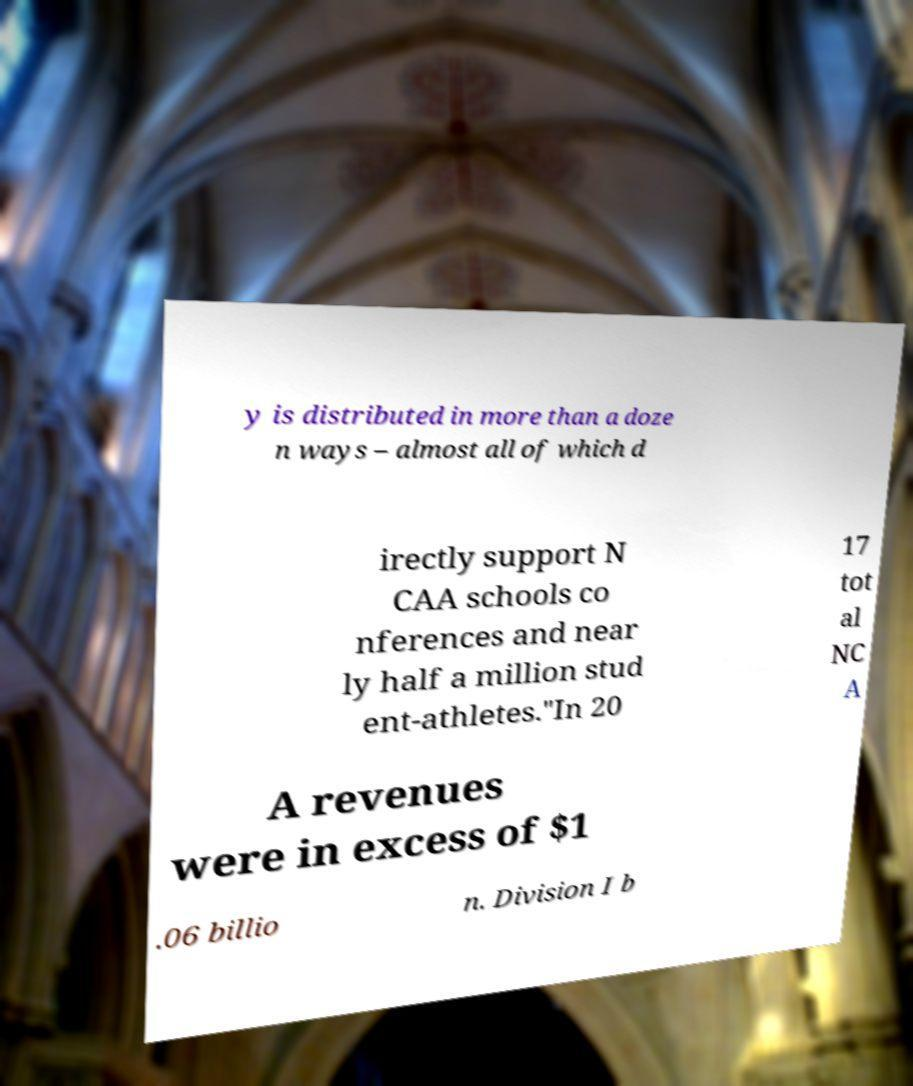What messages or text are displayed in this image? I need them in a readable, typed format. y is distributed in more than a doze n ways – almost all of which d irectly support N CAA schools co nferences and near ly half a million stud ent-athletes."In 20 17 tot al NC A A revenues were in excess of $1 .06 billio n. Division I b 